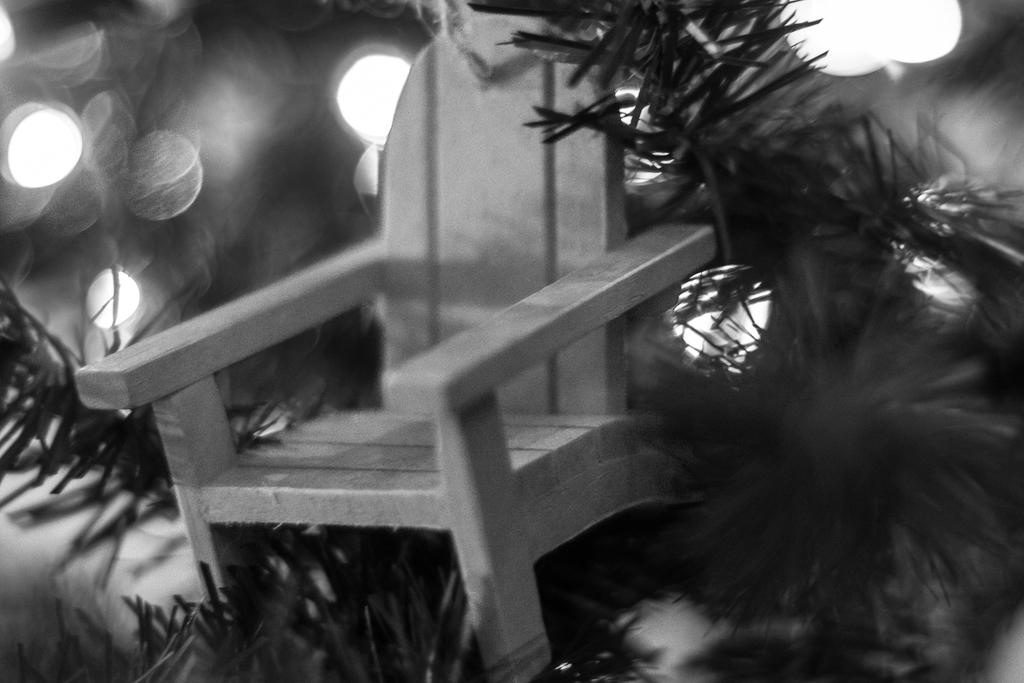What type of furniture is present in the image? There is a chair in the image. What other objects or elements can be seen in the image? There are plants in the image. What type of nail is being used to hold the chair together in the image? There is no nail visible in the image, and the chair's construction is not mentioned. 